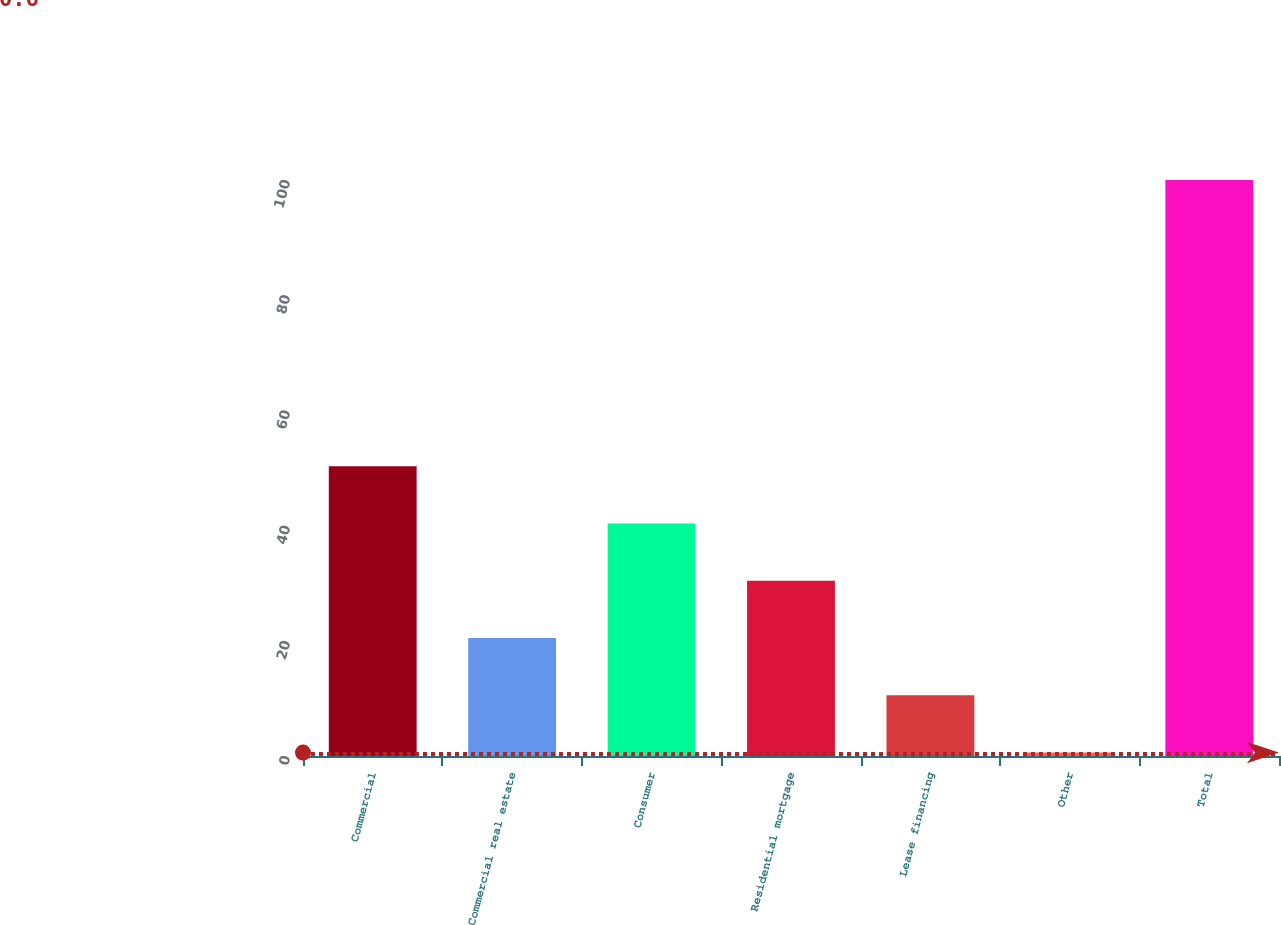Convert chart. <chart><loc_0><loc_0><loc_500><loc_500><bar_chart><fcel>Commercial<fcel>Commercial real estate<fcel>Consumer<fcel>Residential mortgage<fcel>Lease financing<fcel>Other<fcel>Total<nl><fcel>50.3<fcel>20.48<fcel>40.36<fcel>30.42<fcel>10.54<fcel>0.6<fcel>100<nl></chart> 